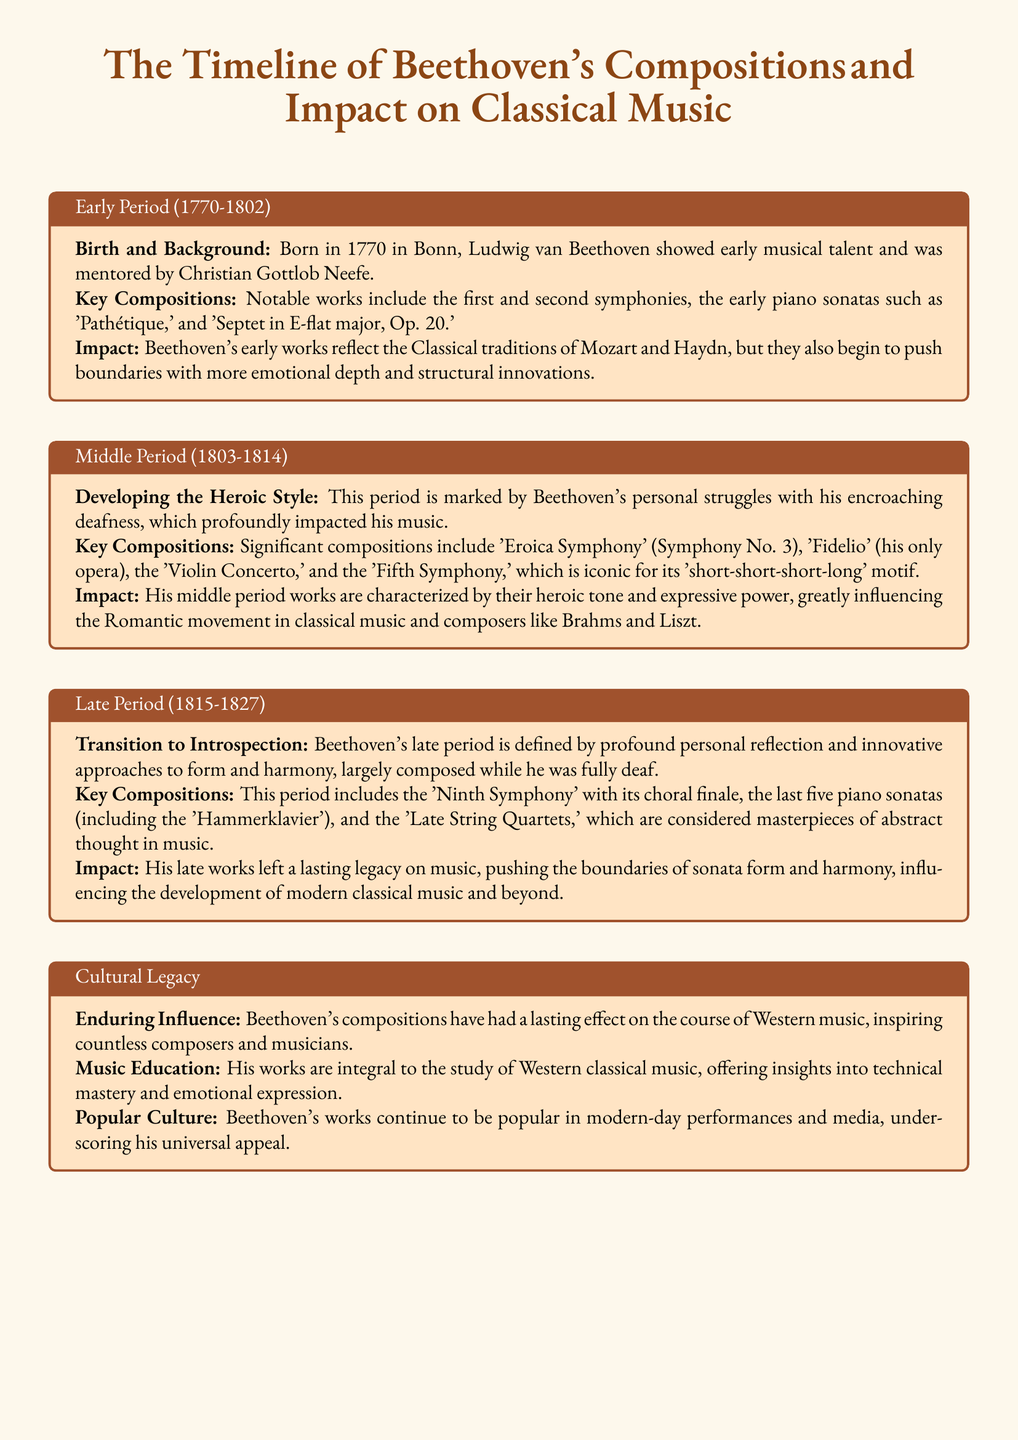What year was Beethoven born? The document states that Beethoven was born in 1770.
Answer: 1770 What are notable works from Beethoven's Early Period? The document lists 'Pathétique' and 'Septet in E-flat major, Op. 20' among others as key compositions from his early works.
Answer: 'Pathétique', 'Septet in E-flat major, Op. 20' Which symphony is known for the 'short-short-short-long' motif? The document mentions that the 'Fifth Symphony' is iconic for this motif.
Answer: Fifth Symphony What period did Beethoven's personal struggles with deafness occur? The document states that this struggle significantly impacted his music during the Middle Period (1803-1814).
Answer: Middle Period Which composition includes the choral finale? According to the document, the 'Ninth Symphony' features this choral finale.
Answer: Ninth Symphony What type of legacy did Beethoven leave in music education? The document mentions that his works are integral to the study of Western classical music.
Answer: Integral to the study of Western classical music What key aspect characterizes Beethoven's Late Period compositions? The document describes his late period as one defined by profound personal reflection and innovative approaches to form and harmony.
Answer: Profound personal reflection Which two composers were influenced by Beethoven's middle period works? The document specifically mentions Brahms and Liszt as composers influenced by this period.
Answer: Brahms, Liszt In which categories did Beethoven's compositions push boundaries? The document specifies that they pushed boundaries in emotional depth and structural innovations.
Answer: Emotional depth, structural innovations 